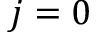Convert formula to latex. <formula><loc_0><loc_0><loc_500><loc_500>j = 0</formula> 